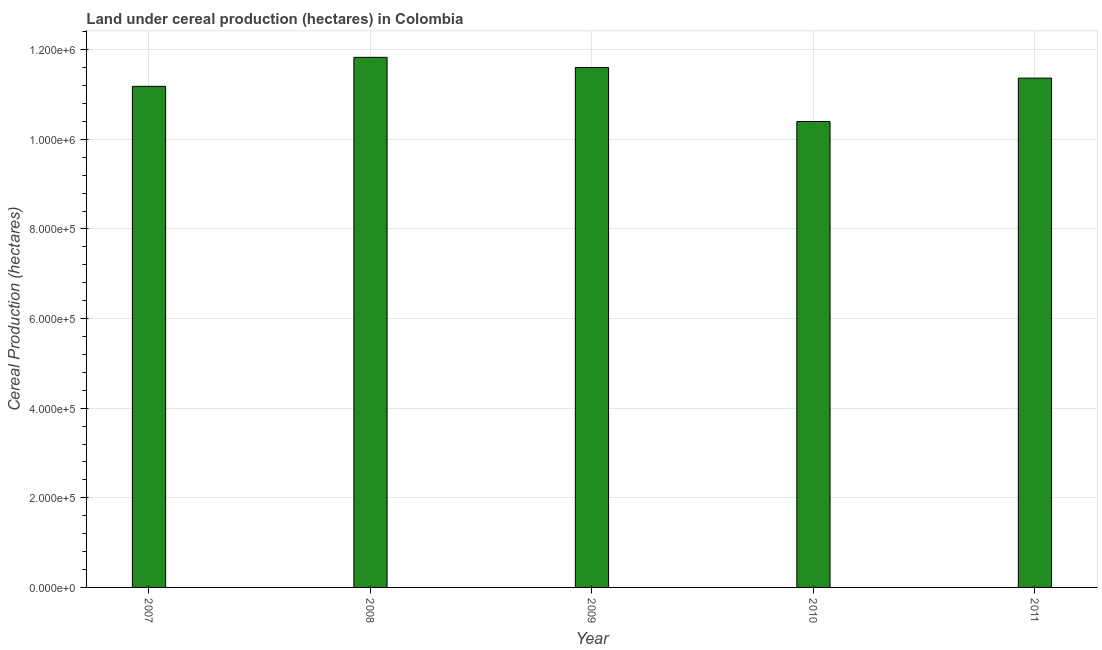Does the graph contain any zero values?
Make the answer very short. No. What is the title of the graph?
Keep it short and to the point. Land under cereal production (hectares) in Colombia. What is the label or title of the Y-axis?
Offer a very short reply. Cereal Production (hectares). What is the land under cereal production in 2007?
Ensure brevity in your answer.  1.12e+06. Across all years, what is the maximum land under cereal production?
Give a very brief answer. 1.18e+06. Across all years, what is the minimum land under cereal production?
Offer a terse response. 1.04e+06. In which year was the land under cereal production minimum?
Your answer should be compact. 2010. What is the sum of the land under cereal production?
Give a very brief answer. 5.64e+06. What is the difference between the land under cereal production in 2009 and 2011?
Your response must be concise. 2.38e+04. What is the average land under cereal production per year?
Provide a succinct answer. 1.13e+06. What is the median land under cereal production?
Provide a succinct answer. 1.14e+06. Do a majority of the years between 2009 and 2011 (inclusive) have land under cereal production greater than 40000 hectares?
Give a very brief answer. Yes. What is the ratio of the land under cereal production in 2007 to that in 2010?
Offer a terse response. 1.07. Is the difference between the land under cereal production in 2008 and 2010 greater than the difference between any two years?
Your answer should be compact. Yes. What is the difference between the highest and the second highest land under cereal production?
Offer a very short reply. 2.27e+04. What is the difference between the highest and the lowest land under cereal production?
Keep it short and to the point. 1.43e+05. Are all the bars in the graph horizontal?
Provide a short and direct response. No. Are the values on the major ticks of Y-axis written in scientific E-notation?
Make the answer very short. Yes. What is the Cereal Production (hectares) of 2007?
Give a very brief answer. 1.12e+06. What is the Cereal Production (hectares) in 2008?
Provide a short and direct response. 1.18e+06. What is the Cereal Production (hectares) in 2009?
Your answer should be very brief. 1.16e+06. What is the Cereal Production (hectares) in 2010?
Keep it short and to the point. 1.04e+06. What is the Cereal Production (hectares) in 2011?
Offer a very short reply. 1.14e+06. What is the difference between the Cereal Production (hectares) in 2007 and 2008?
Provide a short and direct response. -6.48e+04. What is the difference between the Cereal Production (hectares) in 2007 and 2009?
Your answer should be compact. -4.21e+04. What is the difference between the Cereal Production (hectares) in 2007 and 2010?
Keep it short and to the point. 7.84e+04. What is the difference between the Cereal Production (hectares) in 2007 and 2011?
Make the answer very short. -1.83e+04. What is the difference between the Cereal Production (hectares) in 2008 and 2009?
Offer a very short reply. 2.27e+04. What is the difference between the Cereal Production (hectares) in 2008 and 2010?
Your answer should be compact. 1.43e+05. What is the difference between the Cereal Production (hectares) in 2008 and 2011?
Keep it short and to the point. 4.64e+04. What is the difference between the Cereal Production (hectares) in 2009 and 2010?
Keep it short and to the point. 1.21e+05. What is the difference between the Cereal Production (hectares) in 2009 and 2011?
Provide a succinct answer. 2.38e+04. What is the difference between the Cereal Production (hectares) in 2010 and 2011?
Provide a short and direct response. -9.67e+04. What is the ratio of the Cereal Production (hectares) in 2007 to that in 2008?
Your answer should be very brief. 0.94. What is the ratio of the Cereal Production (hectares) in 2007 to that in 2009?
Provide a succinct answer. 0.96. What is the ratio of the Cereal Production (hectares) in 2007 to that in 2010?
Give a very brief answer. 1.07. What is the ratio of the Cereal Production (hectares) in 2007 to that in 2011?
Give a very brief answer. 0.98. What is the ratio of the Cereal Production (hectares) in 2008 to that in 2010?
Offer a terse response. 1.14. What is the ratio of the Cereal Production (hectares) in 2008 to that in 2011?
Give a very brief answer. 1.04. What is the ratio of the Cereal Production (hectares) in 2009 to that in 2010?
Ensure brevity in your answer.  1.12. What is the ratio of the Cereal Production (hectares) in 2010 to that in 2011?
Your answer should be compact. 0.92. 